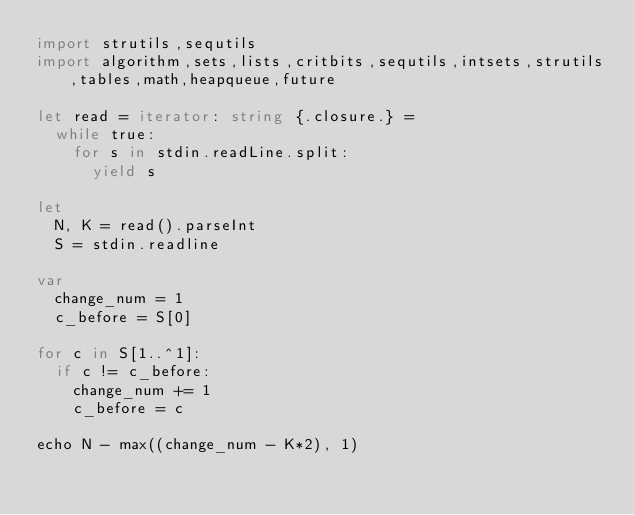<code> <loc_0><loc_0><loc_500><loc_500><_Nim_>import strutils,sequtils
import algorithm,sets,lists,critbits,sequtils,intsets,strutils,tables,math,heapqueue,future

let read = iterator: string {.closure.} =
  while true:
    for s in stdin.readLine.split:
      yield s

let
  N, K = read().parseInt
  S = stdin.readline

var
  change_num = 1
  c_before = S[0]

for c in S[1..^1]:
  if c != c_before:
    change_num += 1
    c_before = c

echo N - max((change_num - K*2), 1)
</code> 